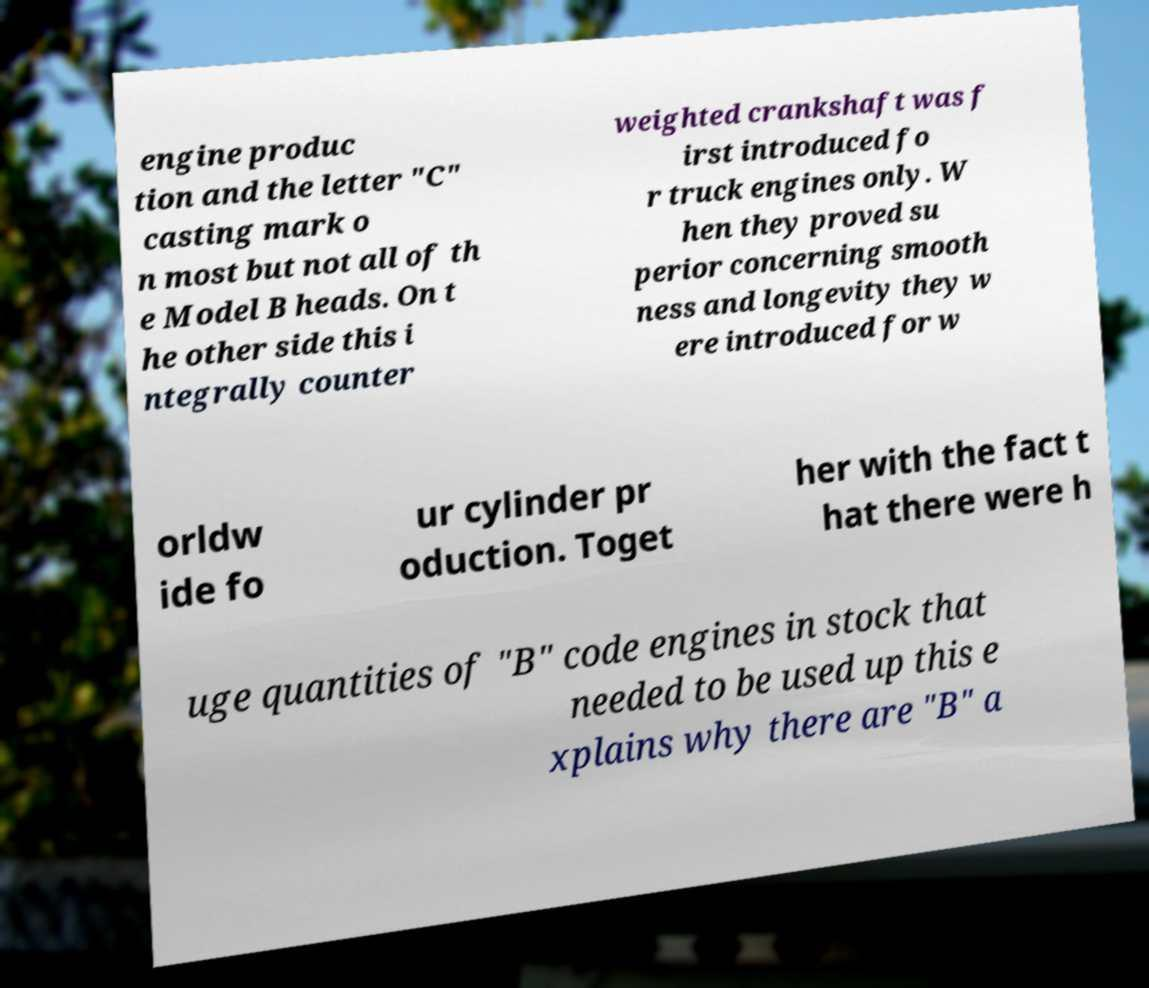Could you assist in decoding the text presented in this image and type it out clearly? engine produc tion and the letter "C" casting mark o n most but not all of th e Model B heads. On t he other side this i ntegrally counter weighted crankshaft was f irst introduced fo r truck engines only. W hen they proved su perior concerning smooth ness and longevity they w ere introduced for w orldw ide fo ur cylinder pr oduction. Toget her with the fact t hat there were h uge quantities of "B" code engines in stock that needed to be used up this e xplains why there are "B" a 